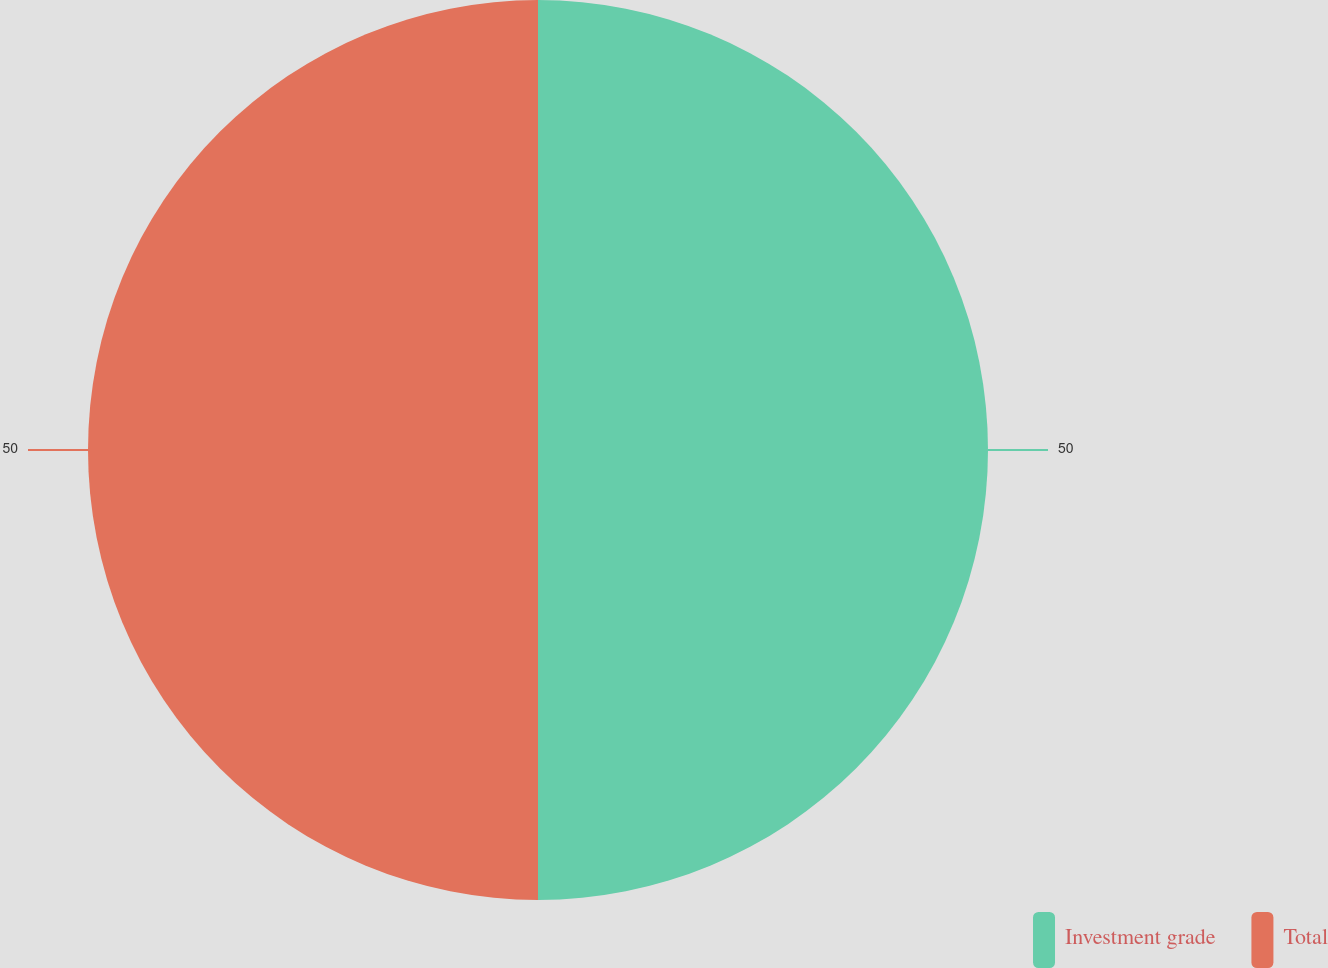<chart> <loc_0><loc_0><loc_500><loc_500><pie_chart><fcel>Investment grade<fcel>Total<nl><fcel>50.0%<fcel>50.0%<nl></chart> 